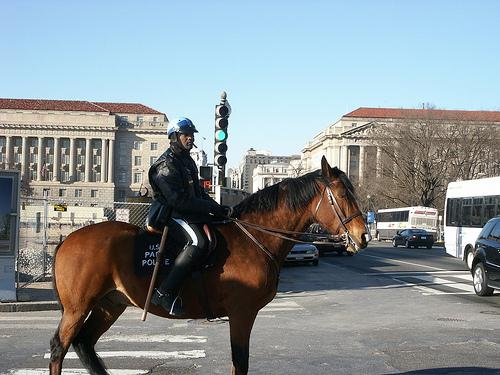Question: where is this picture taken?
Choices:
A. Restaurant.
B. At an intersection on a street.
C. Kitchen.
D. Mountain top.
Answer with the letter. Answer: B Question: how many horses are there?
Choices:
A. 1.
B. 2.
C. 3.
D. 5.
Answer with the letter. Answer: A Question: what are the other vehicles doing?
Choices:
A. Traveling down the road past the policeman and horse.
B. Stopping.
C. Waiting for passerbys.
D. Racing.
Answer with the letter. Answer: A Question: who is sitting on the horse?
Choices:
A. A man.
B. A woman.
C. A jock.
D. A policeman.
Answer with the letter. Answer: D 